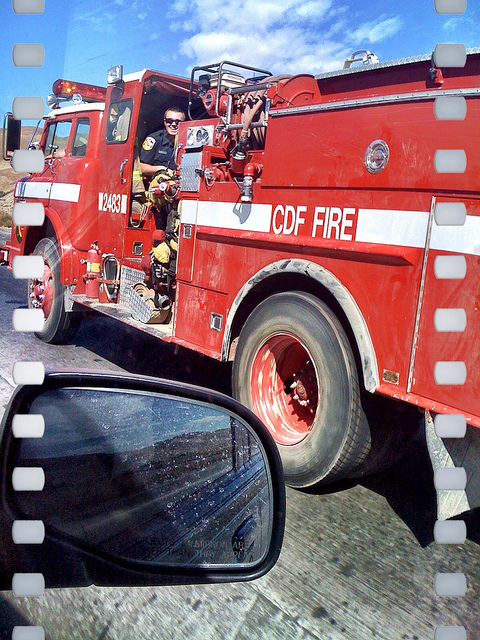Identify the text contained in this image. CDF FIRE 2483 